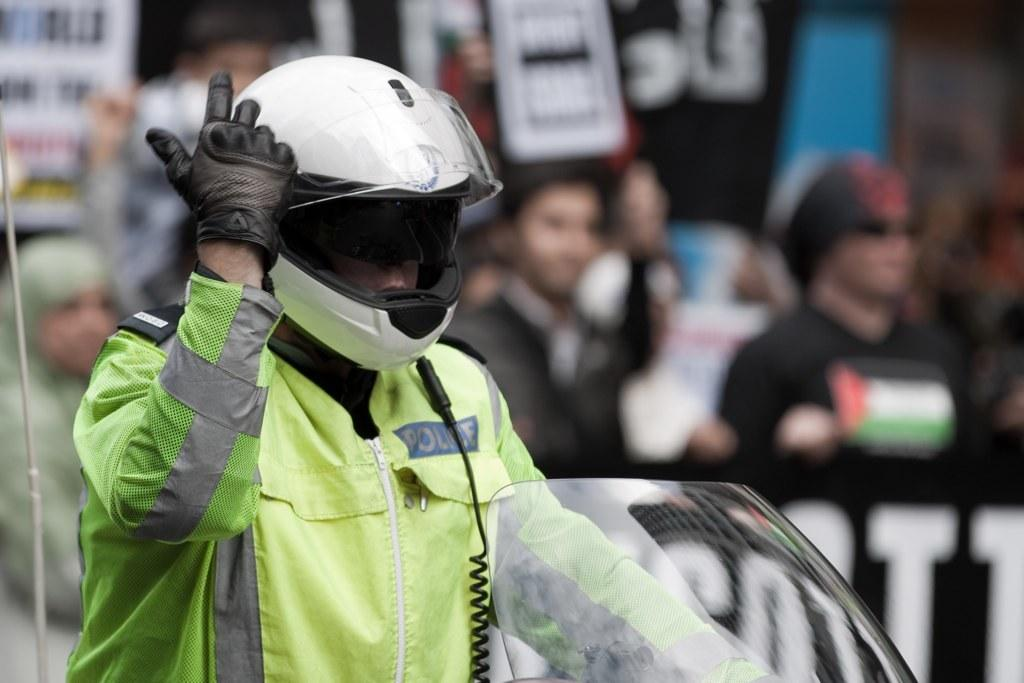What is the main subject of the image? There is a person in the image. Can you describe the surroundings of the person? There is a group of persons in the background of the image. How is the background of the image depicted? The background of the image is blurred. What type of thumb is being used to create humor in the image? There is no thumb or humor present in the image. How many tickets are visible in the image? There are no tickets visible in the image. 